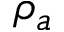Convert formula to latex. <formula><loc_0><loc_0><loc_500><loc_500>\rho _ { a }</formula> 